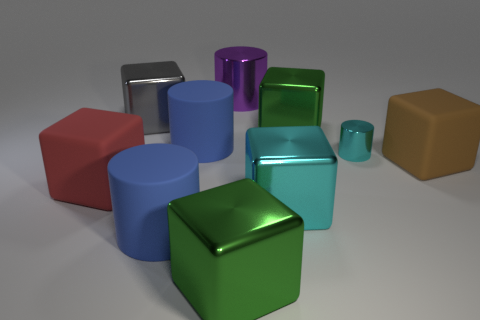Subtract all green blocks. How many blocks are left? 4 Subtract all green cubes. How many cubes are left? 4 Subtract all gray cubes. Subtract all red balls. How many cubes are left? 5 Subtract all cubes. How many objects are left? 4 Subtract all big purple cubes. Subtract all big brown rubber cubes. How many objects are left? 9 Add 1 large green shiny blocks. How many large green shiny blocks are left? 3 Add 1 gray spheres. How many gray spheres exist? 1 Subtract 0 yellow cubes. How many objects are left? 10 